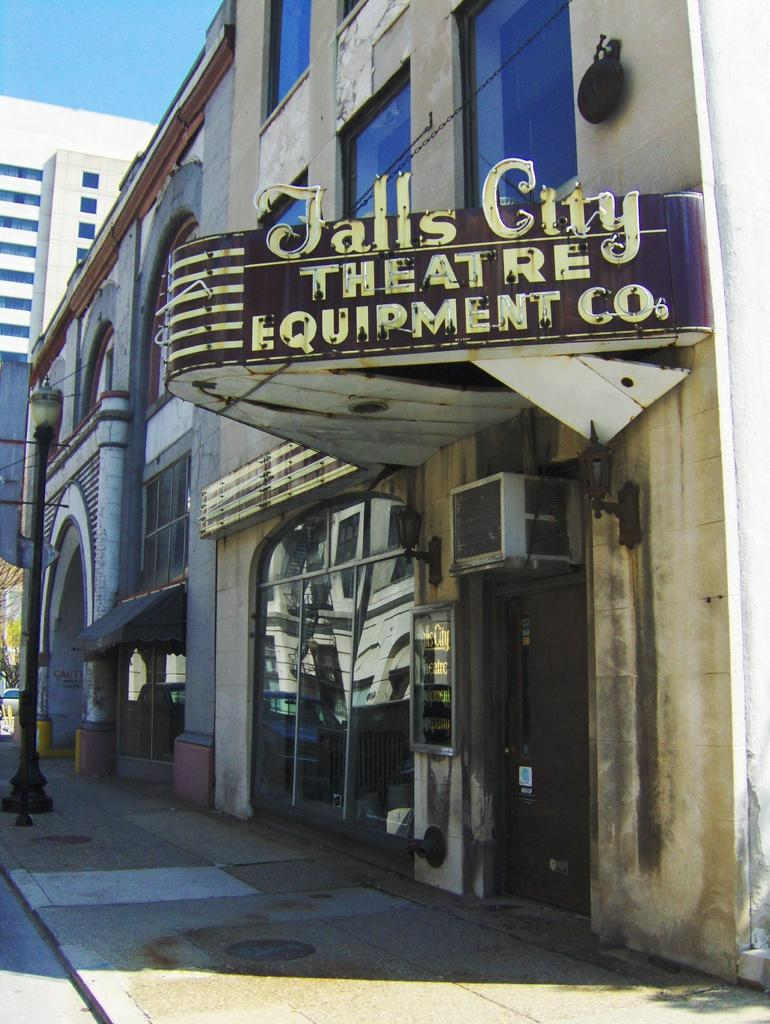What is located in the middle of the image? There is a board in the middle of the image. What type of structures can be seen in the image? There are buildings in the image. What is on the left side of the image? There is a street lamp on the left side of the image. What is visible at the top of the image? The sky is visible at the top of the image. Can you see any goldfish swimming in the sky in the image? There are no goldfish present in the image, and they cannot swim in the sky. What type of creature is interacting with the street lamp in the image? There is no creature interacting with the street lamp in the image; only the street lamp and other objects are present. 